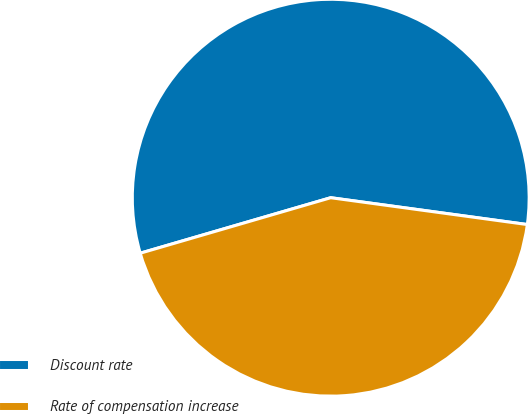<chart> <loc_0><loc_0><loc_500><loc_500><pie_chart><fcel>Discount rate<fcel>Rate of compensation increase<nl><fcel>56.67%<fcel>43.33%<nl></chart> 